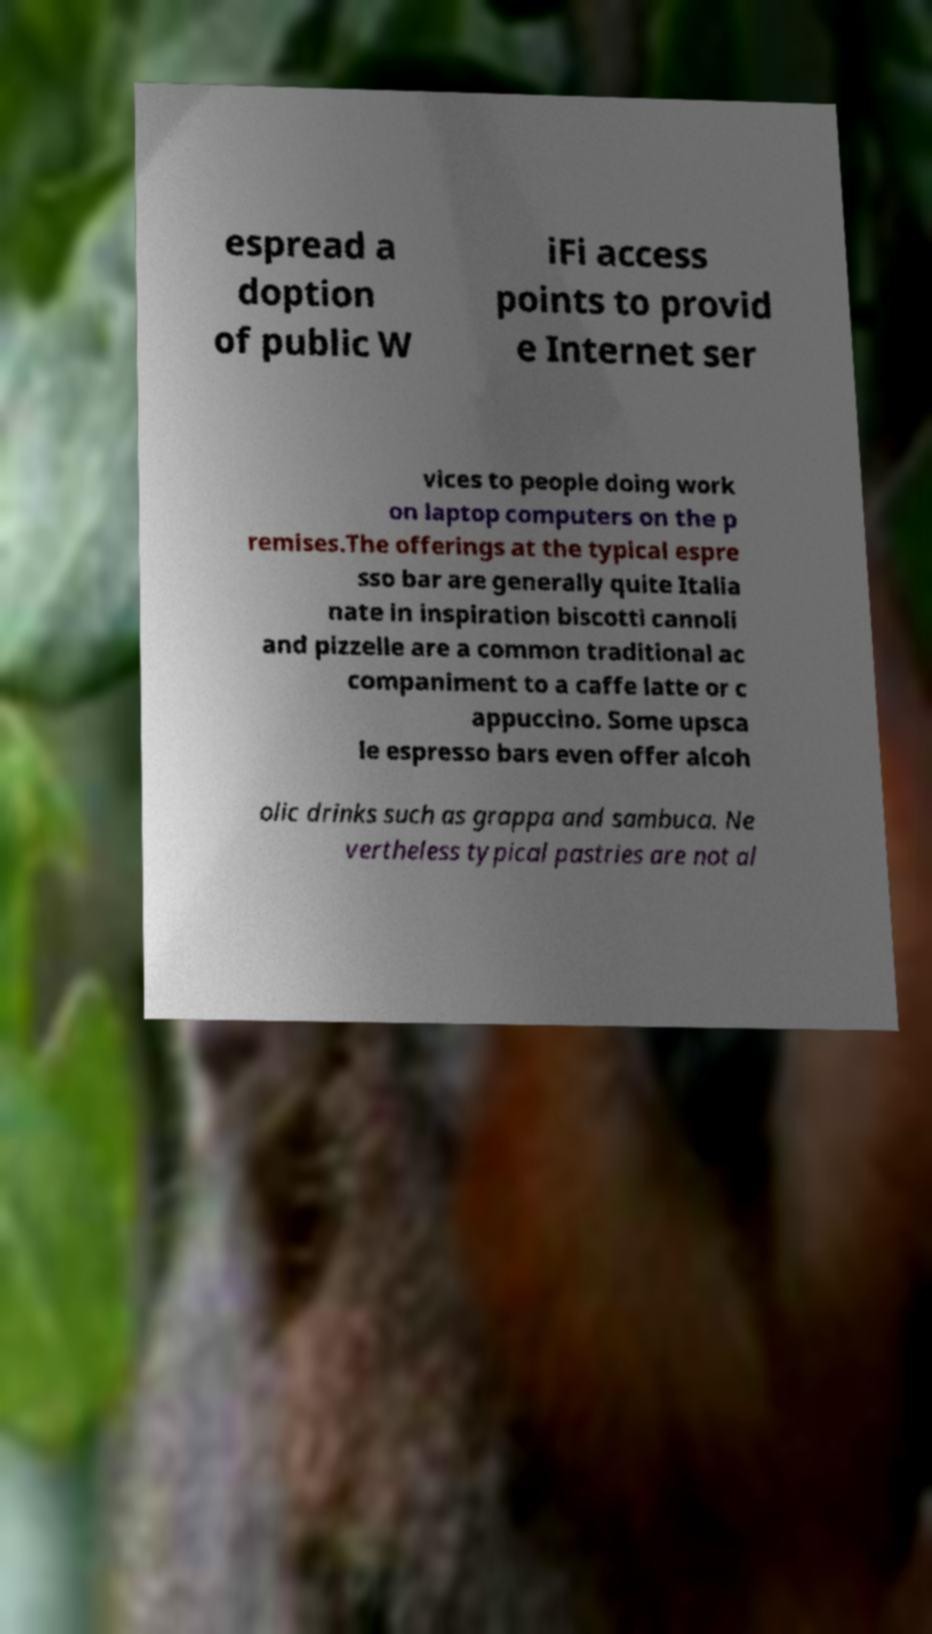Please identify and transcribe the text found in this image. espread a doption of public W iFi access points to provid e Internet ser vices to people doing work on laptop computers on the p remises.The offerings at the typical espre sso bar are generally quite Italia nate in inspiration biscotti cannoli and pizzelle are a common traditional ac companiment to a caffe latte or c appuccino. Some upsca le espresso bars even offer alcoh olic drinks such as grappa and sambuca. Ne vertheless typical pastries are not al 